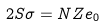<formula> <loc_0><loc_0><loc_500><loc_500>2 S \sigma = N Z e _ { 0 }</formula> 